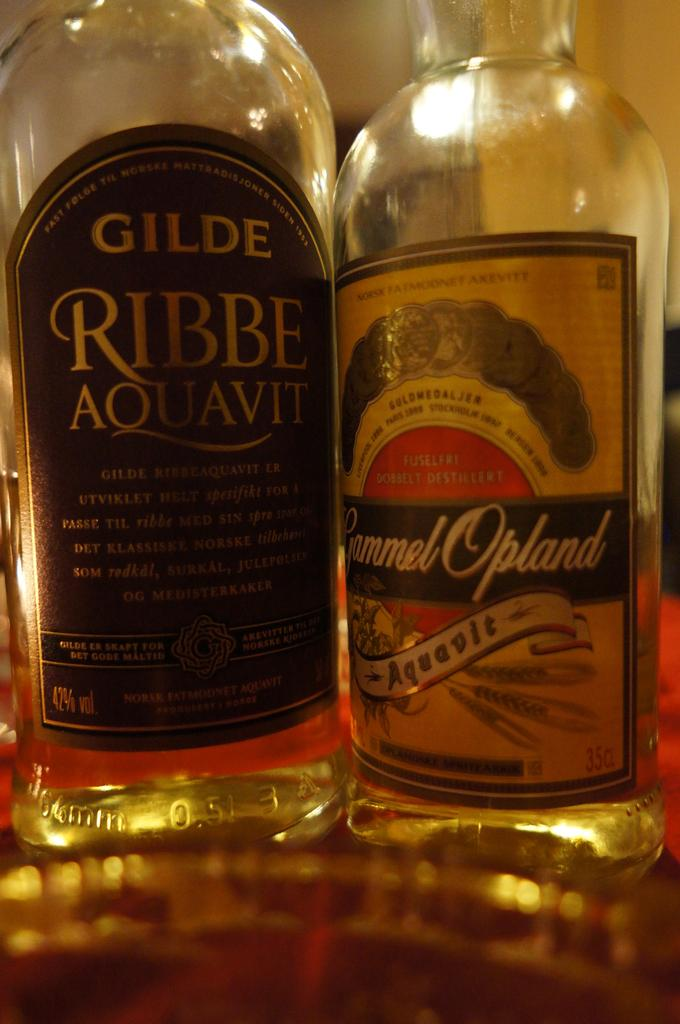<image>
Relay a brief, clear account of the picture shown. Two bottles of liquor one titled Gilde Ribbe Aquavit and the other is Remmel Opland. 